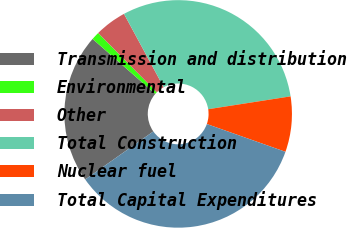<chart> <loc_0><loc_0><loc_500><loc_500><pie_chart><fcel>Transmission and distribution<fcel>Environmental<fcel>Other<fcel>Total Construction<fcel>Nuclear fuel<fcel>Total Capital Expenditures<nl><fcel>21.23%<fcel>1.14%<fcel>4.51%<fcel>30.44%<fcel>7.87%<fcel>34.82%<nl></chart> 